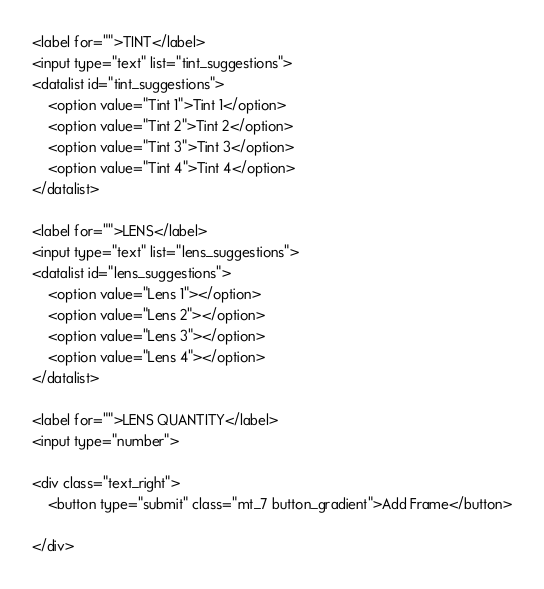<code> <loc_0><loc_0><loc_500><loc_500><_PHP_>
<label for="">TINT</label>
<input type="text" list="tint_suggestions">
<datalist id="tint_suggestions">
    <option value="Tint 1">Tint 1</option>
    <option value="Tint 2">Tint 2</option>
    <option value="Tint 3">Tint 3</option>
    <option value="Tint 4">Tint 4</option>
</datalist>

<label for="">LENS</label>
<input type="text" list="lens_suggestions">
<datalist id="lens_suggestions">
    <option value="Lens 1"></option>
    <option value="Lens 2"></option>
    <option value="Lens 3"></option>
    <option value="Lens 4"></option>
</datalist>

<label for="">LENS QUANTITY</label>
<input type="number">

<div class="text_right">
    <button type="submit" class="mt_7 button_gradient">Add Frame</button>

</div>


</code> 